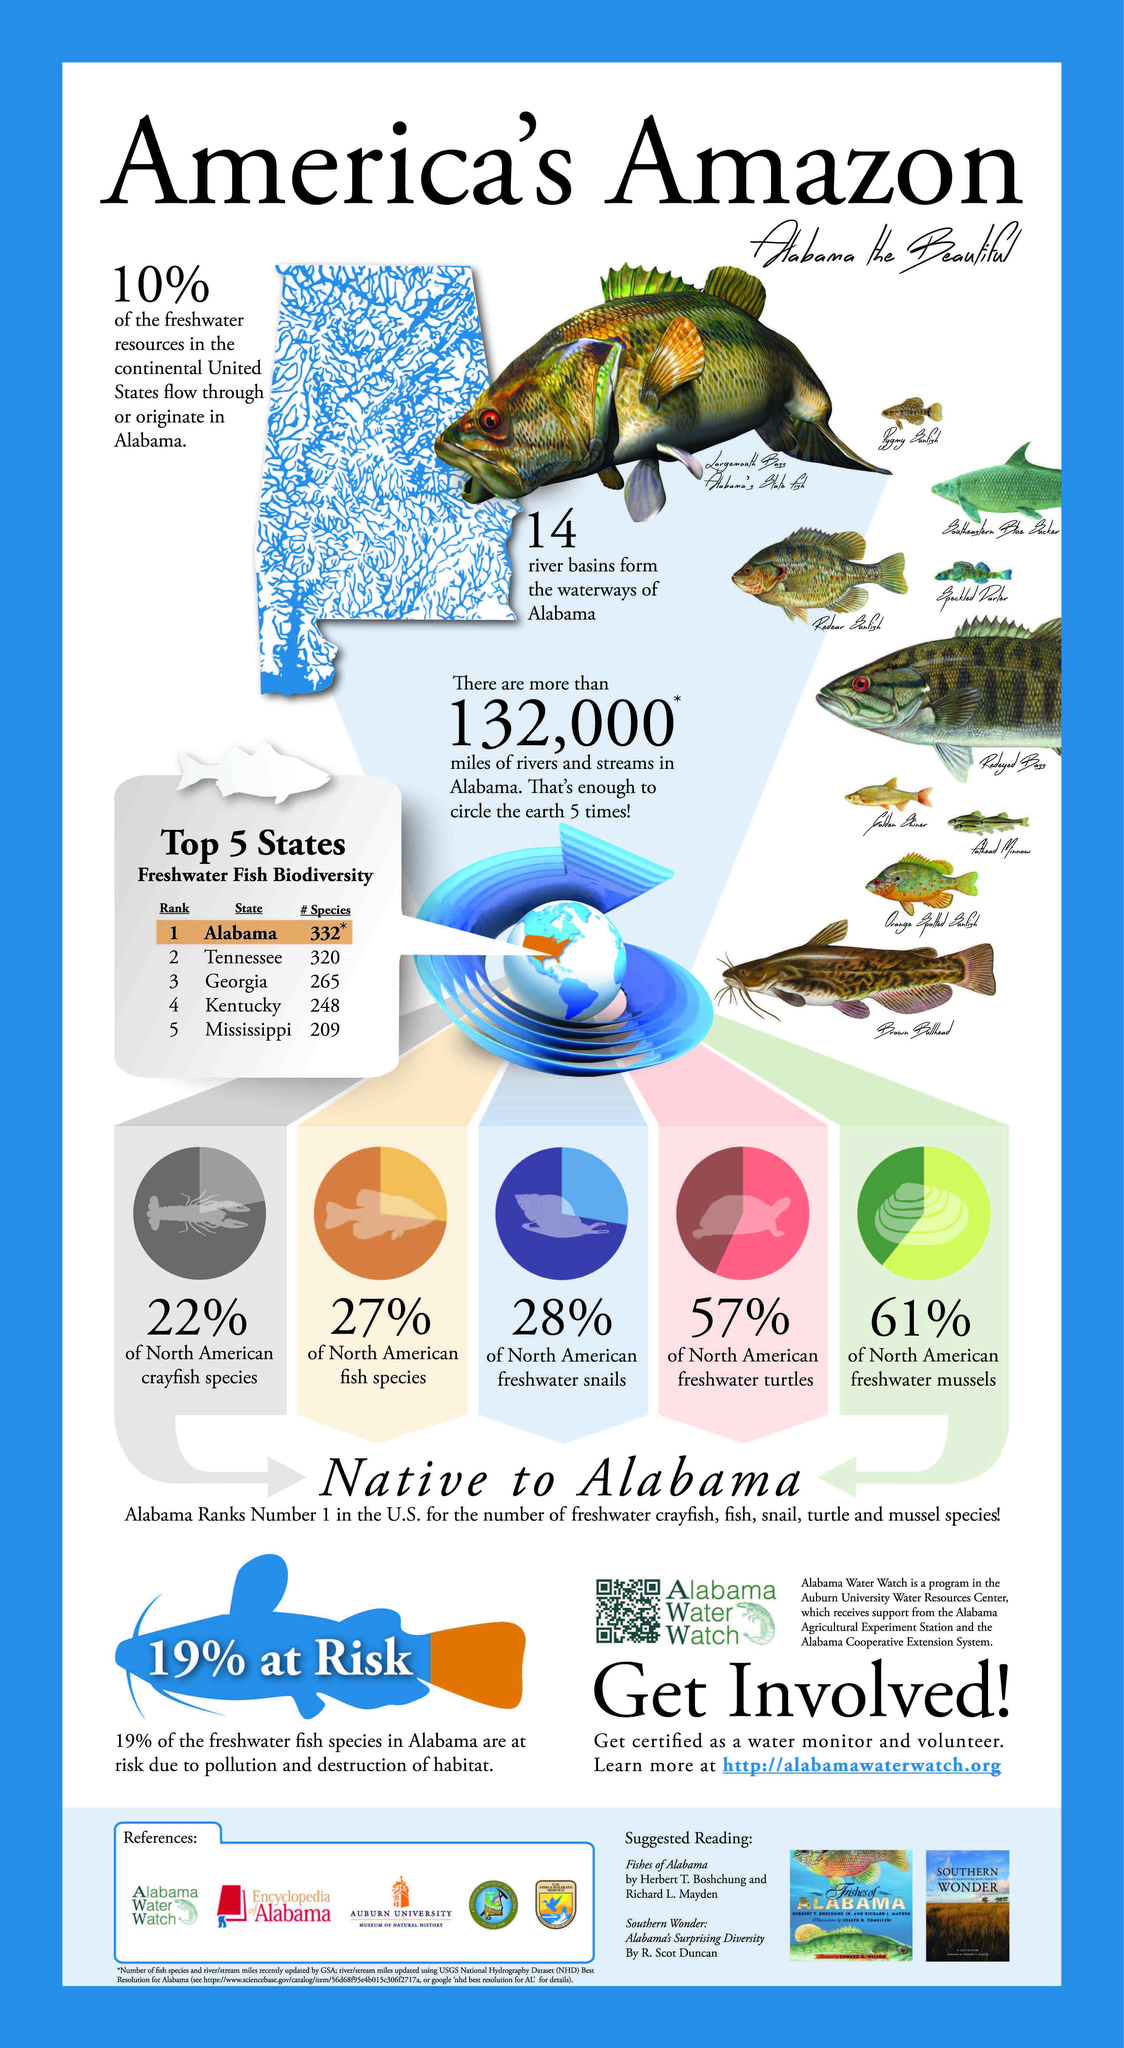Which state in America is ranked no.4 in freshwater fish biodiversity?
Answer the question with a short phrase. Kentucky How many species of freshwater fish are found in Mississippi state of America? 209 How many species of freshwater fish are found in Tennessee? 320 What percentage of North American fish species are found in Alabama? 27% What percentage of North American fresh water snails are found in Alabama? 28% Which state in America is ranked no.3 in freshwater fish biodiversity? Georgia What percentage of North American fresh water turtles are found in Alabama? 57% Which state in America is ranked no.1 in freshwater fish biodiversity? Alabama How many species of freshwater fish are found in Georgia? 265 